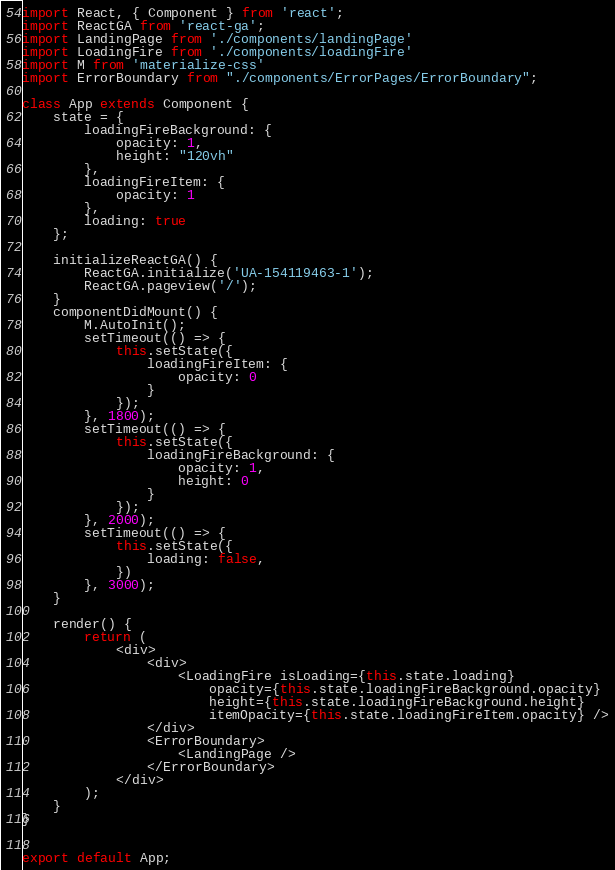<code> <loc_0><loc_0><loc_500><loc_500><_JavaScript_>import React, { Component } from 'react';
import ReactGA from 'react-ga';
import LandingPage from './components/landingPage'
import LoadingFire from './components/loadingFire'
import M from 'materialize-css'
import ErrorBoundary from "./components/ErrorPages/ErrorBoundary";

class App extends Component {
    state = {
        loadingFireBackground: {
            opacity: 1,
            height: "120vh"
        },
        loadingFireItem: {
            opacity: 1
        },
        loading: true
    };

    initializeReactGA() {
        ReactGA.initialize('UA-154119463-1');
        ReactGA.pageview('/');
    }
    componentDidMount() {
        M.AutoInit();
        setTimeout(() => {
            this.setState({
                loadingFireItem: {
                    opacity: 0
                }
            });
        }, 1800);
        setTimeout(() => {
            this.setState({
                loadingFireBackground: {
                    opacity: 1,
                    height: 0
                }
            });
        }, 2000);
        setTimeout(() => {
            this.setState({
                loading: false,
            })
        }, 3000);
    }

    render() {
        return (
            <div>
                <div>
                    <LoadingFire isLoading={this.state.loading}
                        opacity={this.state.loadingFireBackground.opacity}
                        height={this.state.loadingFireBackground.height}
                        itemOpacity={this.state.loadingFireItem.opacity} />
                </div>
                <ErrorBoundary>
                    <LandingPage />
                </ErrorBoundary>
            </div>
        );
    }
}


export default App;
</code> 